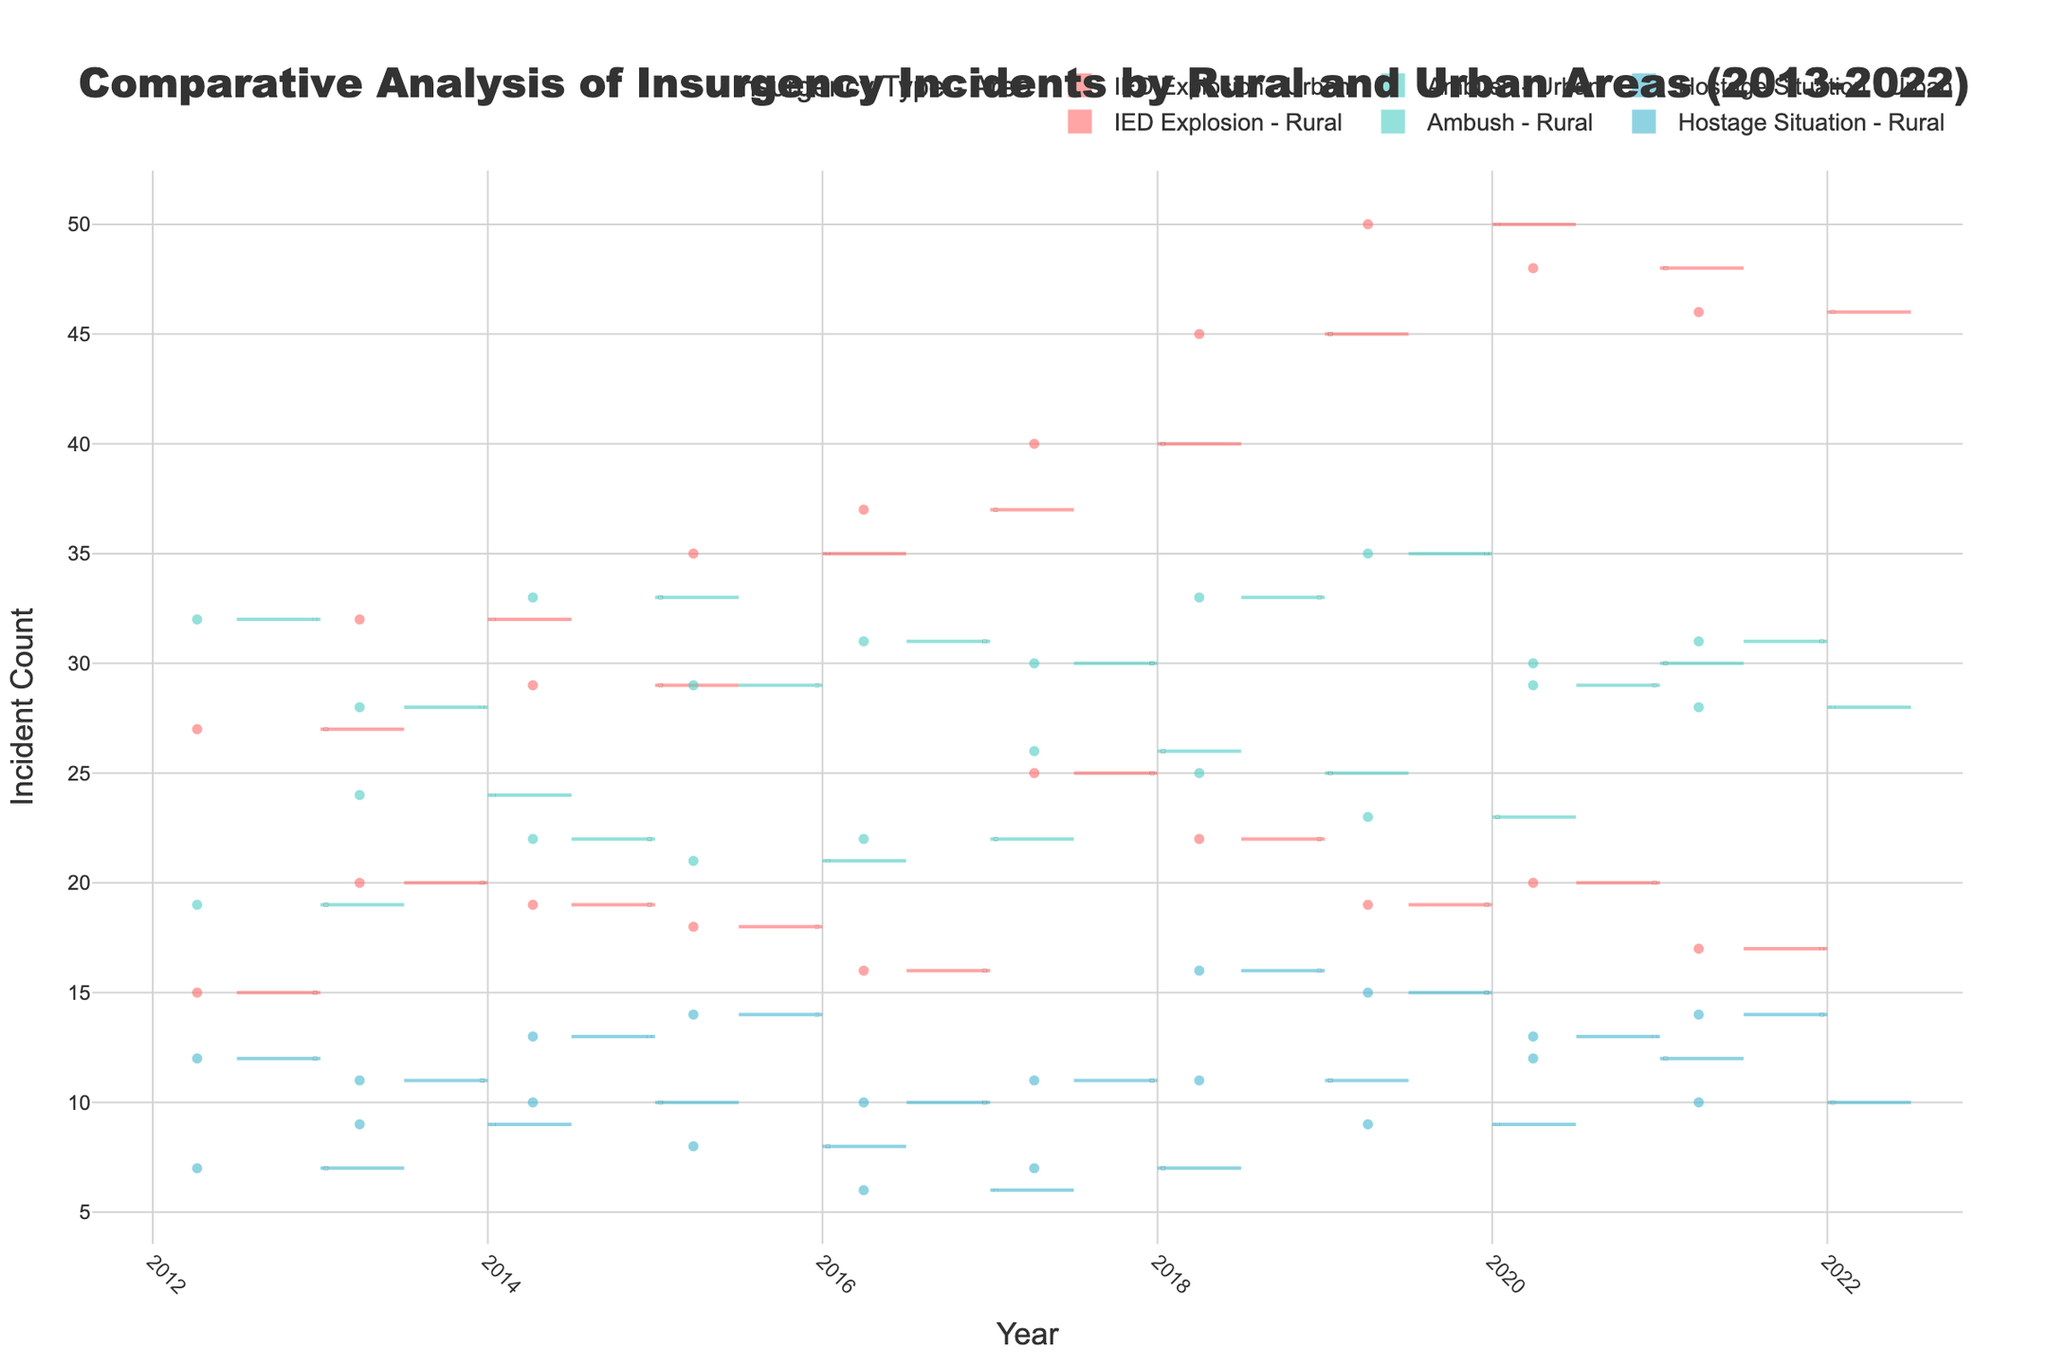what's the title of the figure? The title of a figure is generally located at the top center. You can see the text that's largest and bold, meant to give you an initial understanding of what the figure is about.
Answer: Comparative Analysis of Insurgency Incidents by Rural and Urban Areas (2013-2022) how many types of insurgency incidents are shown in the figure? To determine the number of types of insurgency incidents, look at the legend or the different colored sections within the figure. Each unique label or color typically represents a different type.
Answer: 3 which area type generally has higher incident counts for IED Explosions? Compare the positions and widths of the violin plots for IED Explosions between Urban and Rural areas across all years. The plot with larger values and wider spreads generally indicates higher incident counts.
Answer: Urban what's the average difference in incident count for Hostage Situations between Urban and Rural areas in 2020? Find the incident counts for Hostage Situations in both Urban (9 incidents) and Rural (15 incidents) areas for the year 2020. Calculate the difference (15 - 9 = 6) and find the average (6/1 = 6).
Answer: 6 which year has the highest overall incident count for Ambushes in Urban areas? Look at the violin plots for Ambushes in Urban areas across all years. The plot with the highest peak and widest spread represents the year with the maximum incidents.
Answer: 2015 is there a noticeable trend in the count of IED Explosion incidents in Rural areas over the decade? Examine the violin plots for IED Explosions in Rural areas over the years. Identify whether the plots show an upward, downward, or no clear trend.
Answer: Generally downward compare the median incident counts for Ambushes in Urban versus Rural areas? Look at the thick line (median) inside the violin plots for Ambushes in both Urban and Rural areas. Compare the positions of these lines to determine which one is higher.
Answer: Urban is higher what's the incident count for Hostage Situations in Urban areas in 2021? Locate the specific violin plot for Hostage Situations in Urban areas for the year 2021, then identify the point that represents the count (usually marked explicitly or can be derived from the position on the y-axis).
Answer: 12 which insurgency type shows the least variation in Rural areas? In a violin plot, the width represents the density of data points. The plot with the least spread indicates the least variation. Compare the widths of violin plots for all insurgency types in Rural areas.
Answer: Hostage Situation compare the interquartile ranges (IQR) for IED Explosions between Urban and Rural areas? In a violin plot, the interquartile range (IQR) is shown by the spread of the box within each plot. Compare the lengths of the boxes in IED Explosion plots for both areas to see which has a larger IQR.
Answer: Urban has a larger IQR 